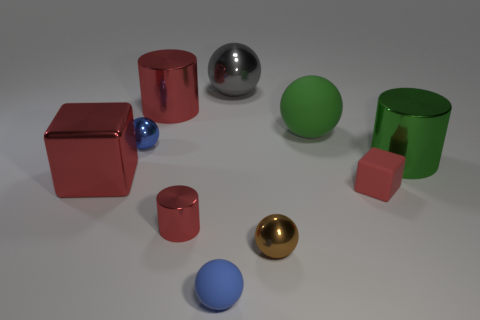Subtract all tiny shiny balls. How many balls are left? 3 Subtract all blocks. How many objects are left? 8 Subtract all blue spheres. How many spheres are left? 3 Subtract all blue cubes. Subtract all gray spheres. How many cubes are left? 2 Subtract all blue spheres. How many green cylinders are left? 1 Subtract all big green rubber cylinders. Subtract all red matte cubes. How many objects are left? 9 Add 4 small cylinders. How many small cylinders are left? 5 Add 4 big brown cylinders. How many big brown cylinders exist? 4 Subtract 0 blue cylinders. How many objects are left? 10 Subtract 1 blocks. How many blocks are left? 1 